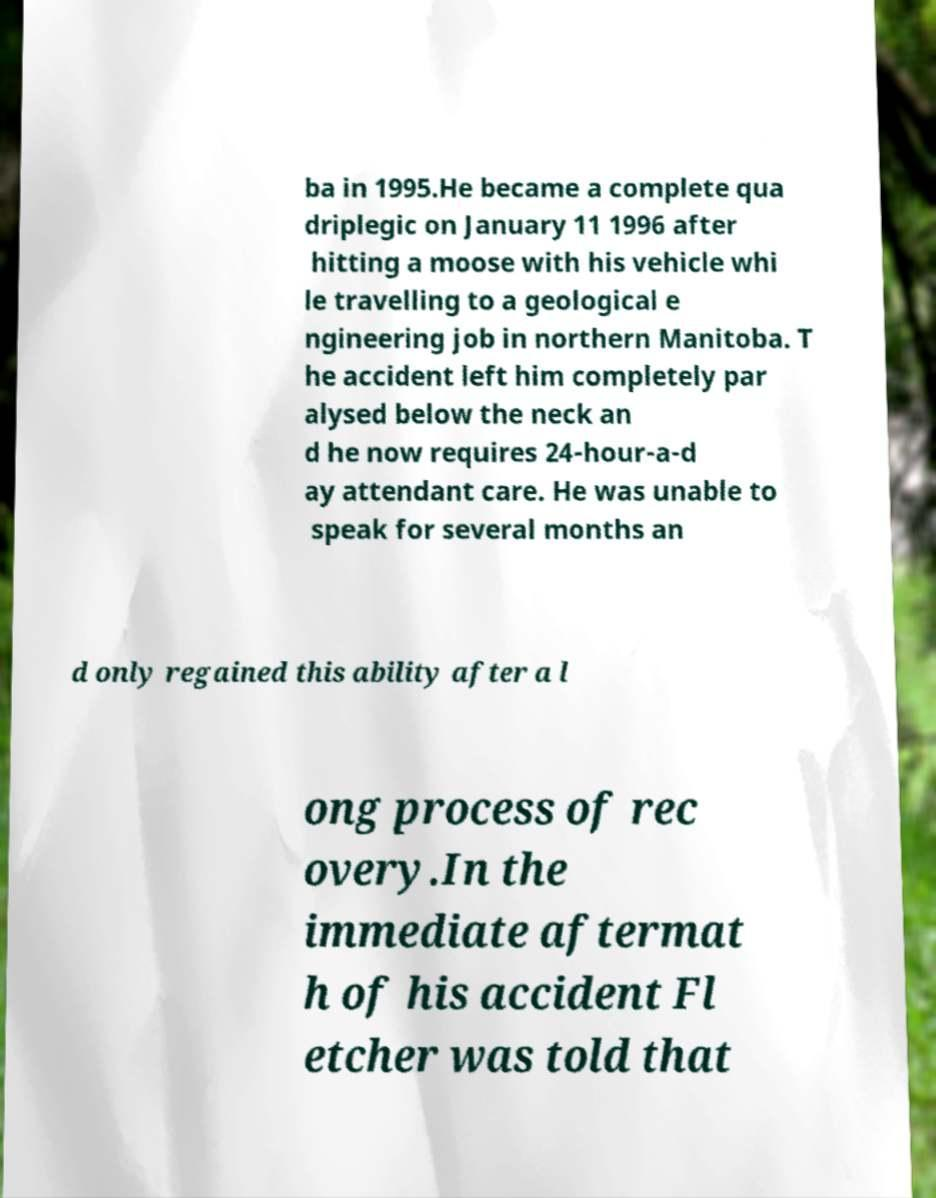Can you read and provide the text displayed in the image?This photo seems to have some interesting text. Can you extract and type it out for me? ba in 1995.He became a complete qua driplegic on January 11 1996 after hitting a moose with his vehicle whi le travelling to a geological e ngineering job in northern Manitoba. T he accident left him completely par alysed below the neck an d he now requires 24-hour-a-d ay attendant care. He was unable to speak for several months an d only regained this ability after a l ong process of rec overy.In the immediate aftermat h of his accident Fl etcher was told that 